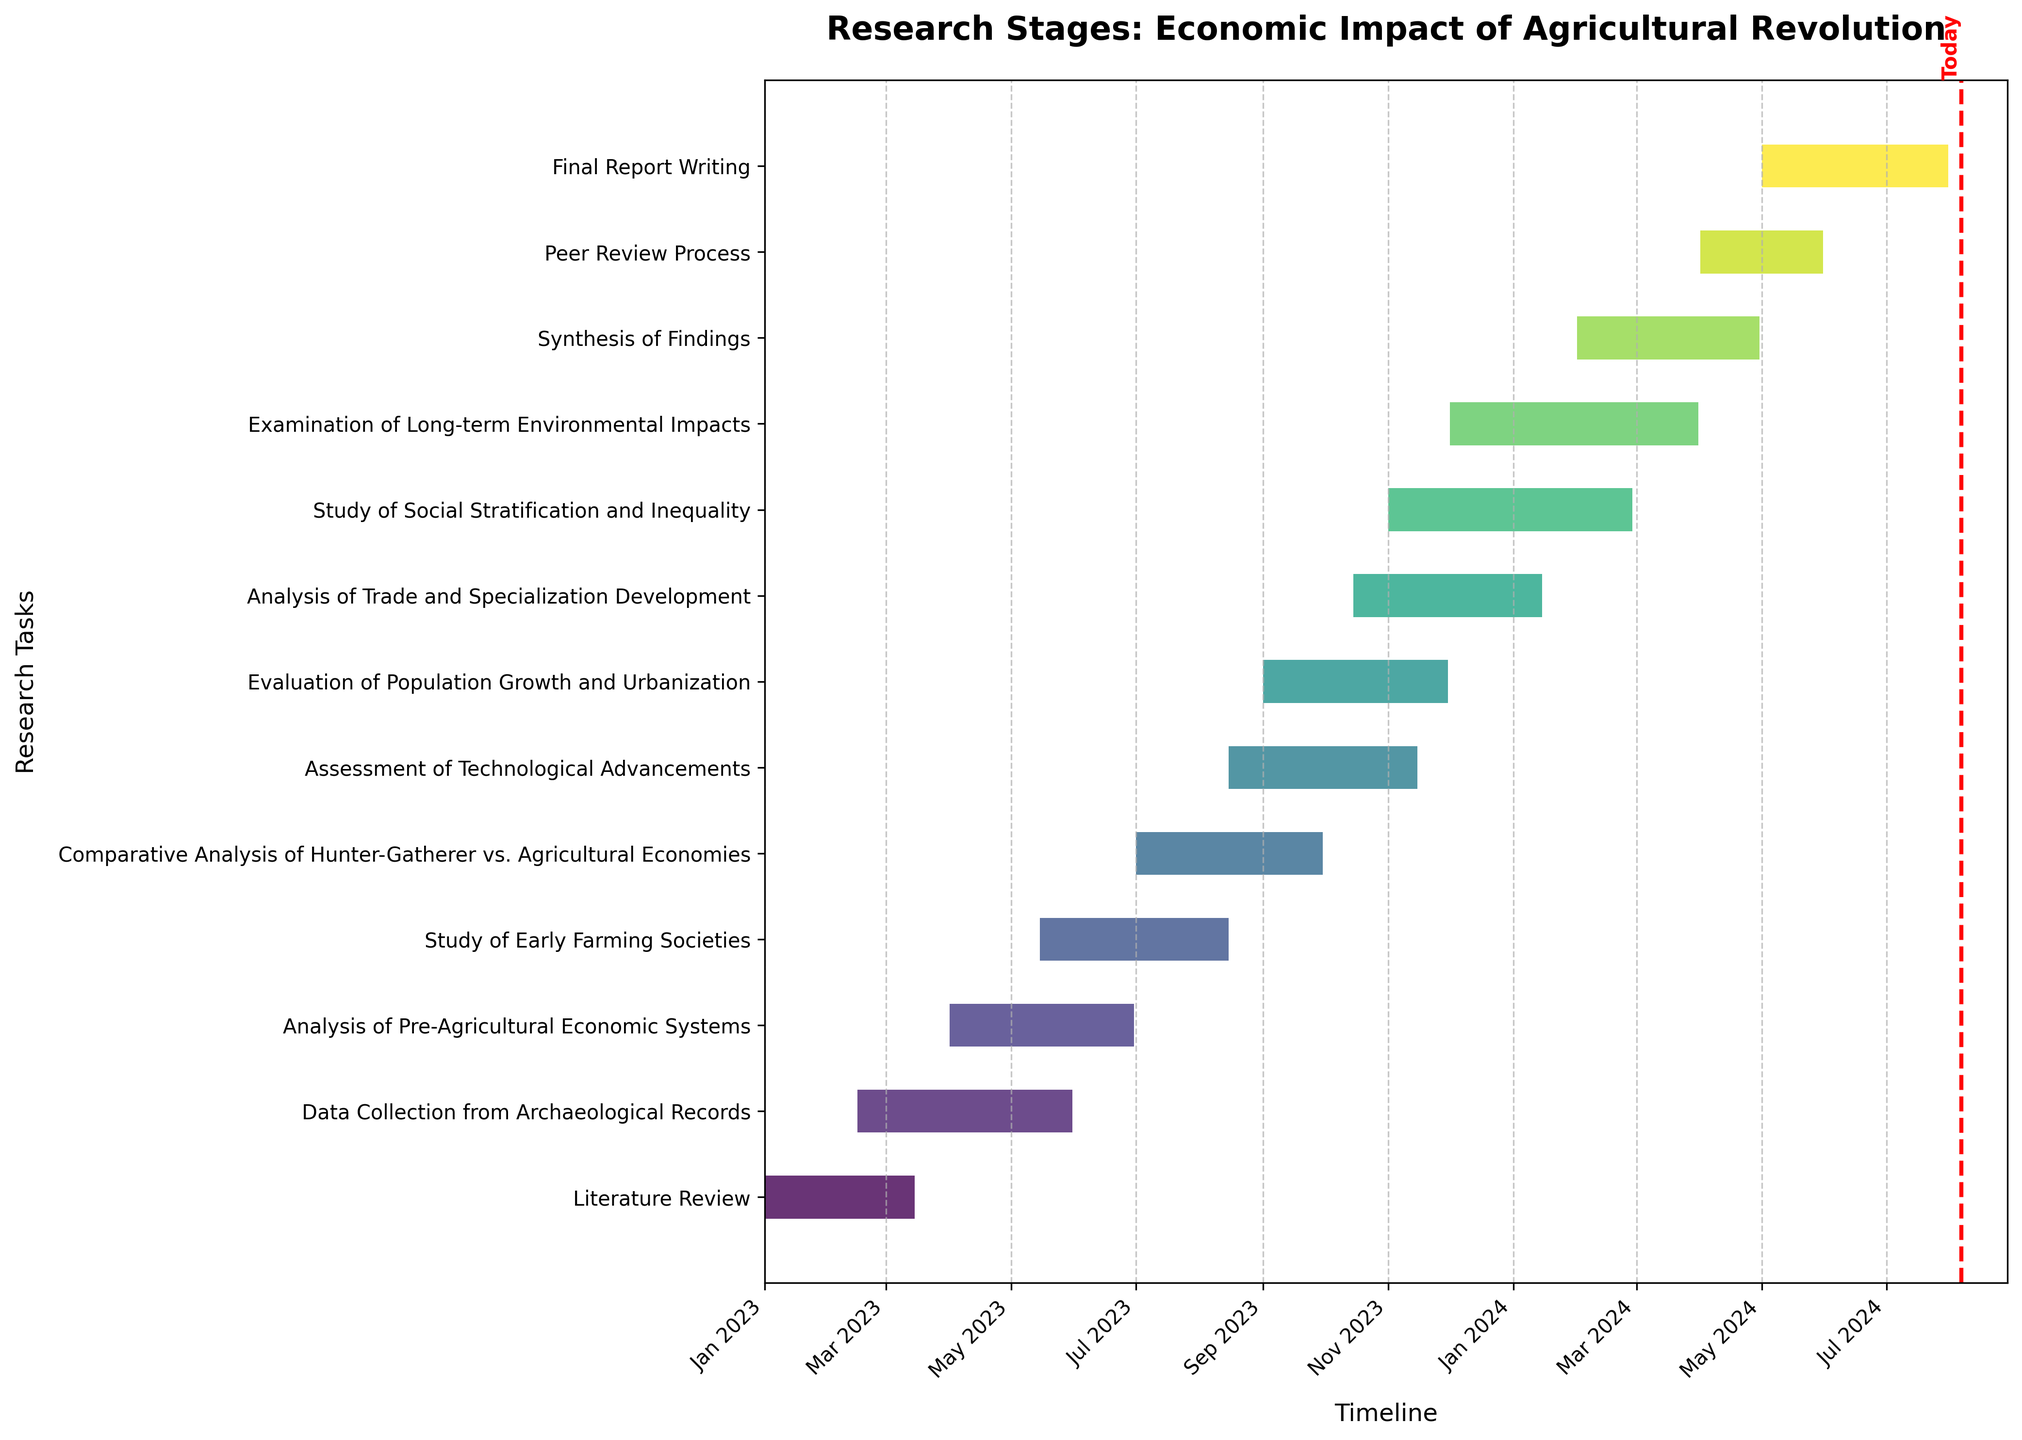What's the title of the chart? The title is located at the top of the chart and reads "Research Stages: Economic Impact of Agricultural Revolution," making it clear what the Gantt chart represents.
Answer: Research Stages: Economic Impact of Agricultural Revolution How many research tasks are shown in the chart? By counting the number of distinct horizontal bars (tasks) on the y-axis, you can see that there are 13 tasks in total.
Answer: 13 What is the duration of the "Data Collection from Archaeological Records" task? The "Data Collection from Archaeological Records" task starts on 2023-02-15 and ends on 2023-05-31. Calculate the duration by subtracting the start date from the end date, which results in approximately 3.5 months.
Answer: Approximately 3.5 months Which task has the shortest duration, and how long is it? By inspecting the lengths of the horizontal bars, we find that the "Literature Review" has the shortest duration. It starts on 2023-01-01 and ends on 2023-03-15, which approximately equals 2.5 months.
Answer: Literature Review, approximately 2.5 months When does the "Examination of Long-term Environmental Impacts" task end? According to the end dates aligned with the tasks, the "Examination of Long-term Environmental Impacts" task ends on 2024-03-31.
Answer: 2024-03-31 How many tasks overlap with the "Analysis of Trade and Specialization Development"? The "Analysis of Trade and Specialization Development" runs from 2023-10-15 to 2024-01-15. By checking the start and end dates of other tasks, we can see that 3 tasks overlap with it: "Evaluation of Population Growth and Urbanization," "Study of Social Stratification and Inequality," and "Examination of Long-term Environmental Impacts."
Answer: 3 Which task starts immediately after "Literature Review"? By looking at the tasks sorted by start dates, the task that starts immediately after "Literature Review," which ends on 2023-03-15, is the "Data Collection from Archaeological Records," starting on 2023-02-15. This task overlaps but starts before the literature review ends. The next non-overlapping task would be "Analysis of Pre-Agricultural Economic Systems" starting on 2023-04-01.
Answer: Data Collection from Archaeological Records How long is the gap between the end of "Literature Review" and the start of "Analysis of Pre-Agricultural Economic Systems"? The "Literature Review" ends on 2023-03-15, and the "Analysis of Pre-Agricultural Economic Systems" starts on 2023-04-01. The gap between these dates is calculated to be 17 days.
Answer: 17 days Which task ends just before "Synthesis of Findings" starts? "Synthesis of Findings" starts on 2024-02-01. Looking at the end dates, the task that ends just before this date is "Study of Social Stratification and Inequality," which ends on 2024-02-28. However, there was a mistake in checking the start date of "Synthesis of Findings" which starts during the "Study of Social Stratification and Inequality."
Answer: Study of Social Stratification and Inequality 